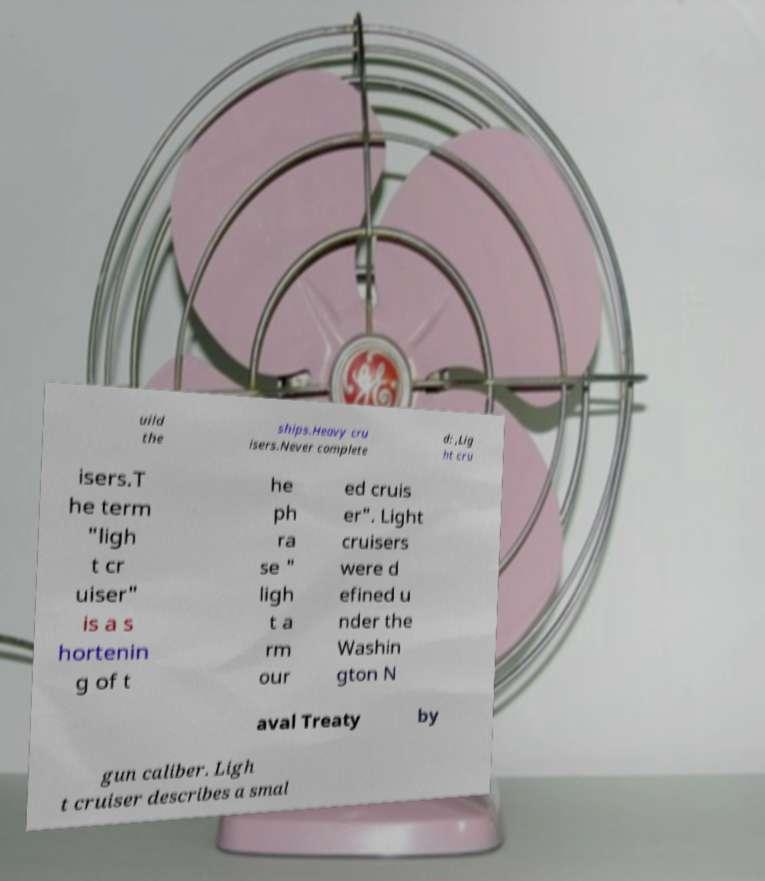Can you read and provide the text displayed in the image?This photo seems to have some interesting text. Can you extract and type it out for me? uild the ships.Heavy cru isers.Never complete d: ,Lig ht cru isers.T he term "ligh t cr uiser" is a s hortenin g of t he ph ra se " ligh t a rm our ed cruis er". Light cruisers were d efined u nder the Washin gton N aval Treaty by gun caliber. Ligh t cruiser describes a smal 